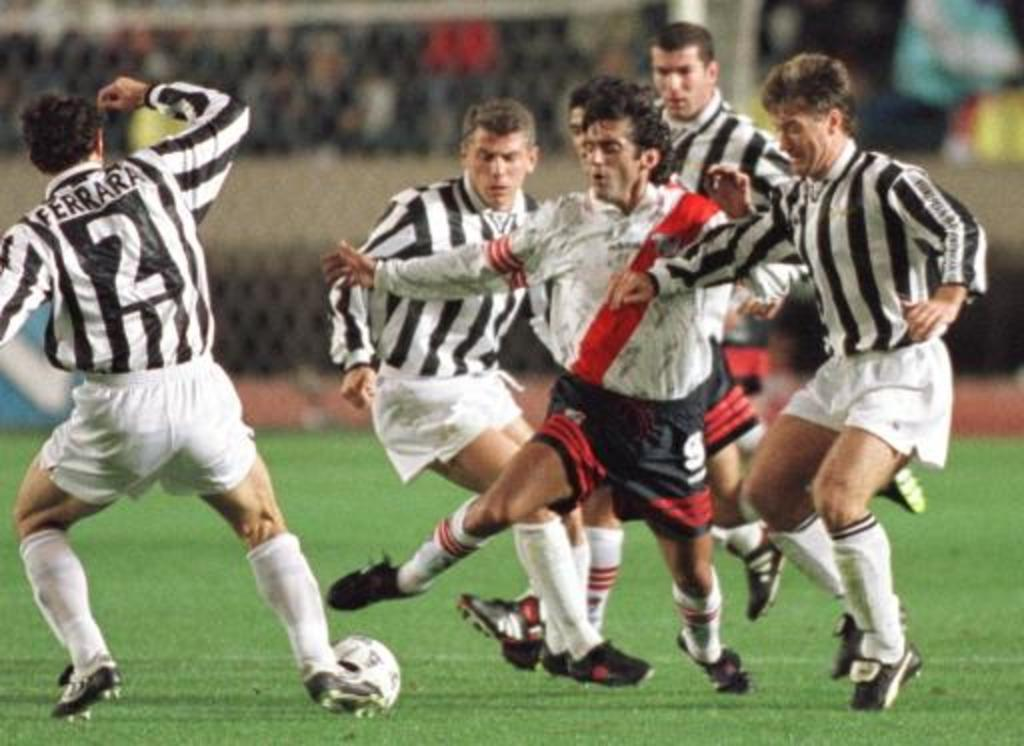What are the people in the image doing? The people are playing football. What type of surface is the football game being played on? The ground has grass. What can be seen in the background of the image? There is a railing visible in the background of the image. What color of paint is being used to kick the football in the image? There is no paint or kicking of paint present in the image; the people are playing football with a ball. 